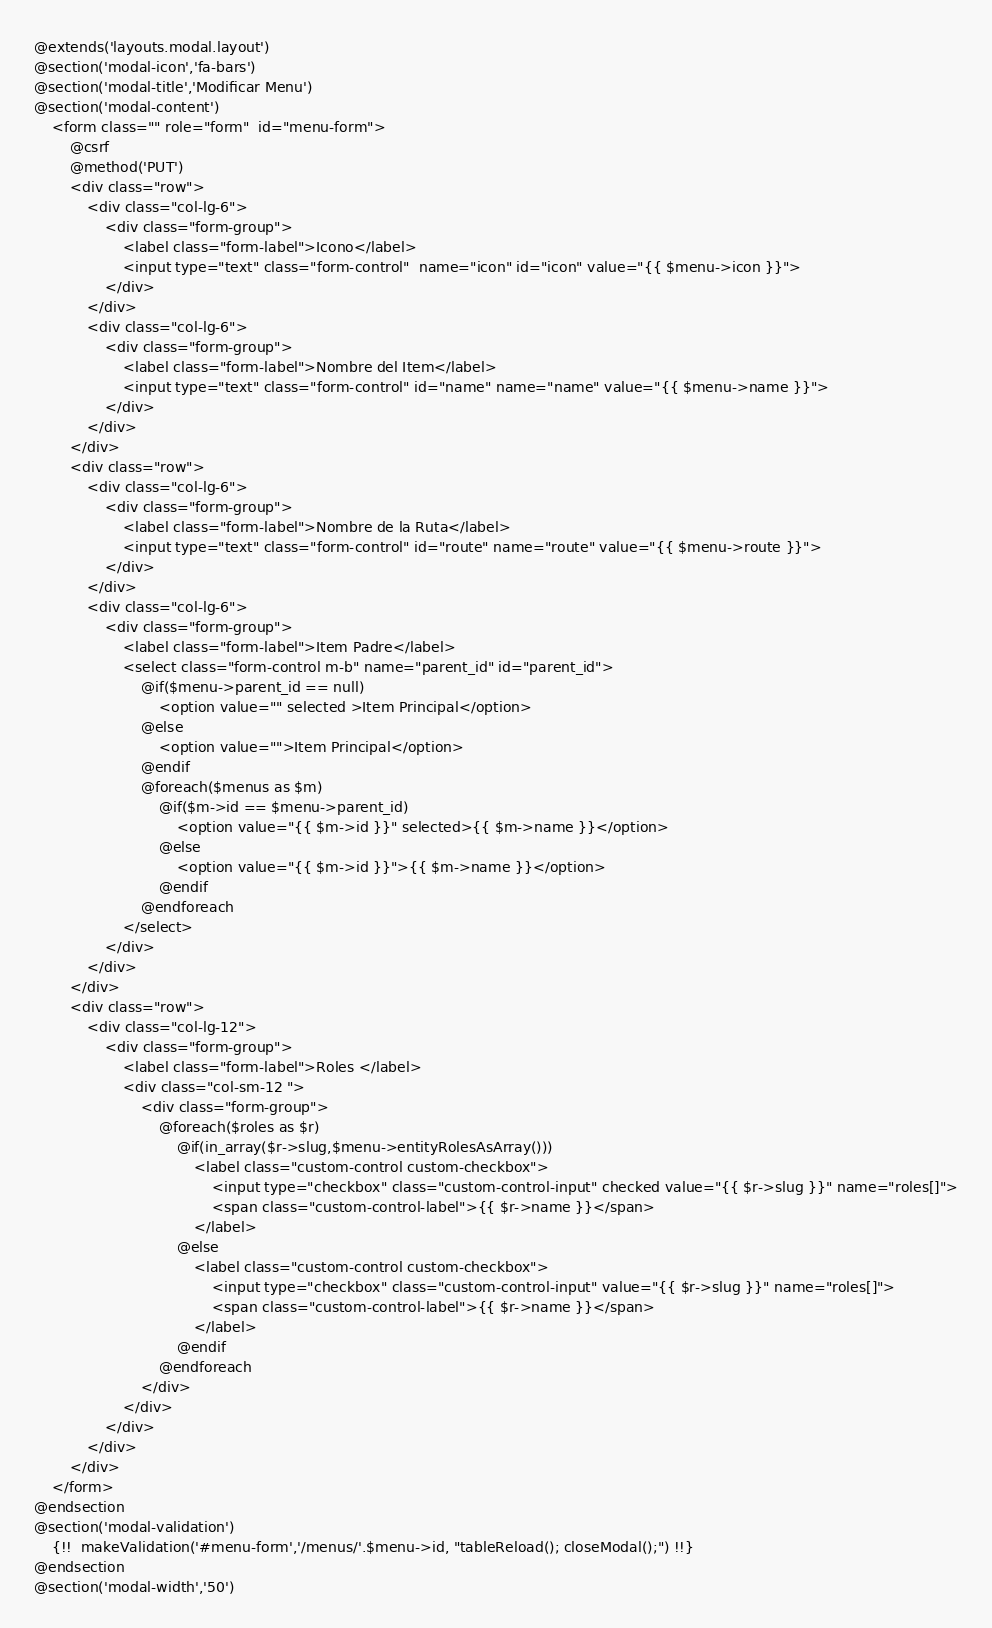Convert code to text. <code><loc_0><loc_0><loc_500><loc_500><_PHP_>@extends('layouts.modal.layout')
@section('modal-icon','fa-bars')
@section('modal-title','Modificar Menu')
@section('modal-content')
    <form class="" role="form"  id="menu-form">
        @csrf
        @method('PUT')
        <div class="row">
            <div class="col-lg-6">
                <div class="form-group">
                    <label class="form-label">Icono</label>
                    <input type="text" class="form-control"  name="icon" id="icon" value="{{ $menu->icon }}">
                </div>
            </div>
            <div class="col-lg-6">
                <div class="form-group">
                    <label class="form-label">Nombre del Item</label>
                    <input type="text" class="form-control" id="name" name="name" value="{{ $menu->name }}">
                </div>
            </div>
        </div>
        <div class="row">
            <div class="col-lg-6">
                <div class="form-group">
                    <label class="form-label">Nombre de la Ruta</label>
                    <input type="text" class="form-control" id="route" name="route" value="{{ $menu->route }}">
                </div>
            </div>
            <div class="col-lg-6">
                <div class="form-group">
                    <label class="form-label">Item Padre</label>
                    <select class="form-control m-b" name="parent_id" id="parent_id">
                        @if($menu->parent_id == null)
                            <option value="" selected >Item Principal</option>
                        @else
                            <option value="">Item Principal</option>
                        @endif
                        @foreach($menus as $m)
                            @if($m->id == $menu->parent_id)
                                <option value="{{ $m->id }}" selected>{{ $m->name }}</option>
                            @else
                                <option value="{{ $m->id }}">{{ $m->name }}</option>
                            @endif
                        @endforeach
                    </select>
                </div>
            </div>
        </div>
        <div class="row">
            <div class="col-lg-12">
                <div class="form-group">
                    <label class="form-label">Roles </label>
                    <div class="col-sm-12 ">
                        <div class="form-group">
                            @foreach($roles as $r)
                                @if(in_array($r->slug,$menu->entityRolesAsArray()))
                                    <label class="custom-control custom-checkbox">
                                        <input type="checkbox" class="custom-control-input" checked value="{{ $r->slug }}" name="roles[]">
                                        <span class="custom-control-label">{{ $r->name }}</span>
                                    </label>
                                @else
                                    <label class="custom-control custom-checkbox">
                                        <input type="checkbox" class="custom-control-input" value="{{ $r->slug }}" name="roles[]">
                                        <span class="custom-control-label">{{ $r->name }}</span>
                                    </label>
                                @endif
                            @endforeach
                        </div>
                    </div>
                </div>
            </div>
        </div>
    </form>
@endsection
@section('modal-validation')
    {!!  makeValidation('#menu-form','/menus/'.$menu->id, "tableReload(); closeModal();") !!}
@endsection
@section('modal-width','50')
</code> 